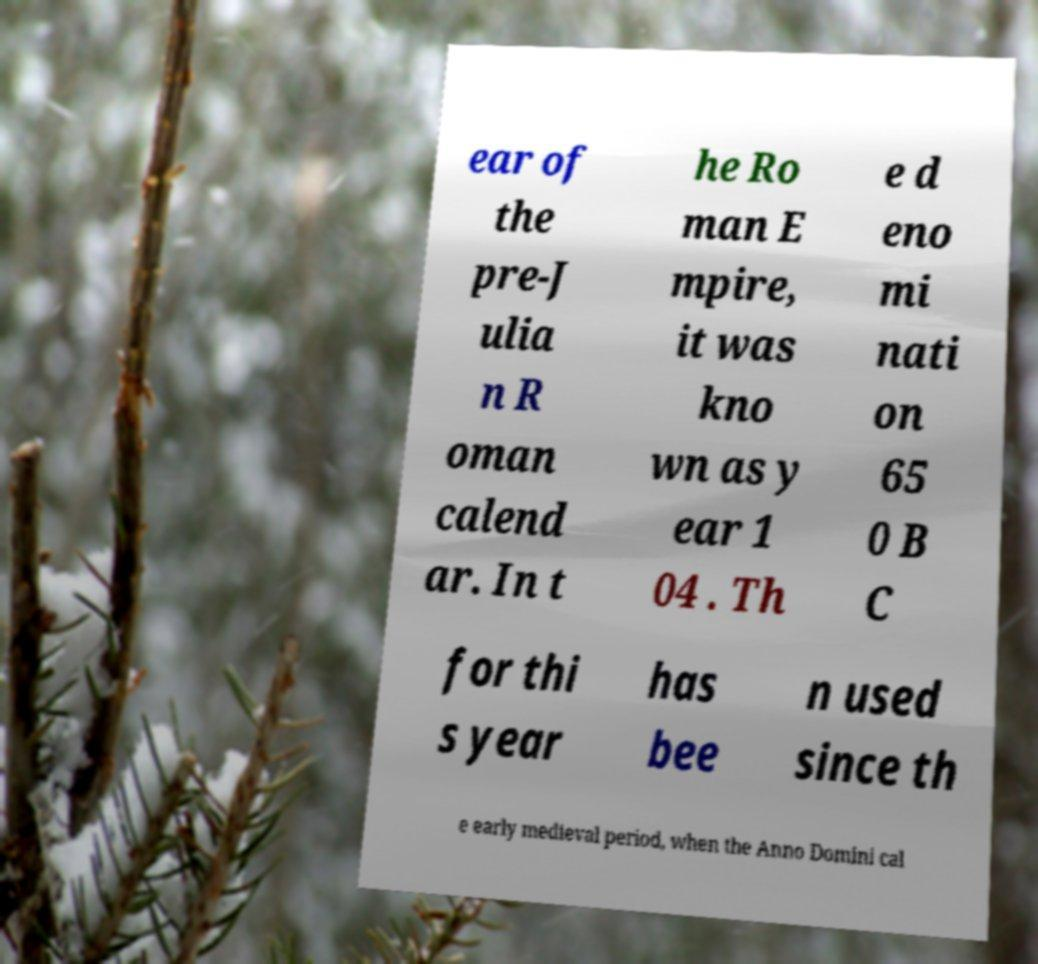For documentation purposes, I need the text within this image transcribed. Could you provide that? ear of the pre-J ulia n R oman calend ar. In t he Ro man E mpire, it was kno wn as y ear 1 04 . Th e d eno mi nati on 65 0 B C for thi s year has bee n used since th e early medieval period, when the Anno Domini cal 